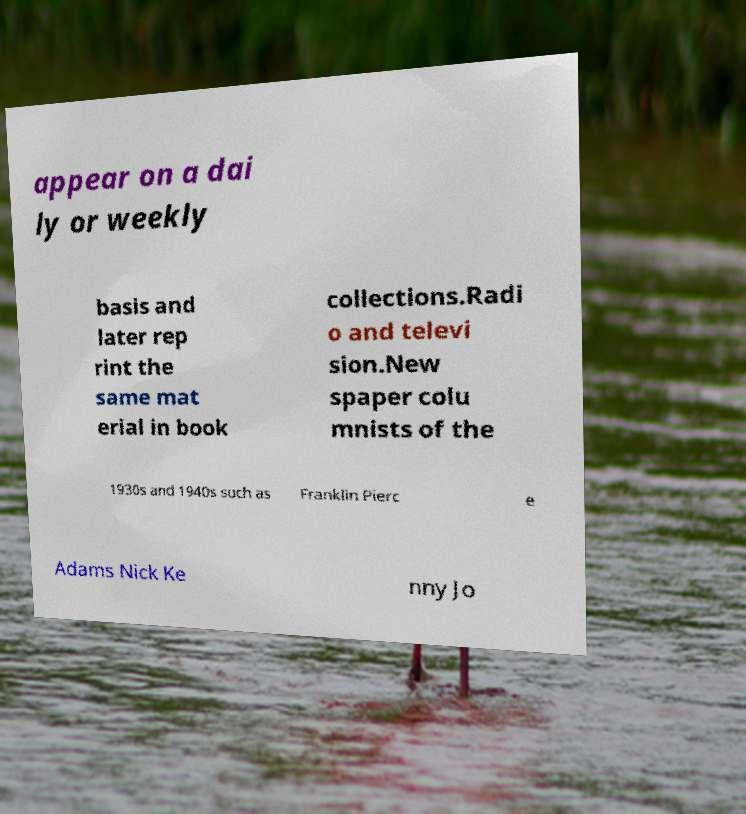Could you assist in decoding the text presented in this image and type it out clearly? appear on a dai ly or weekly basis and later rep rint the same mat erial in book collections.Radi o and televi sion.New spaper colu mnists of the 1930s and 1940s such as Franklin Pierc e Adams Nick Ke nny Jo 